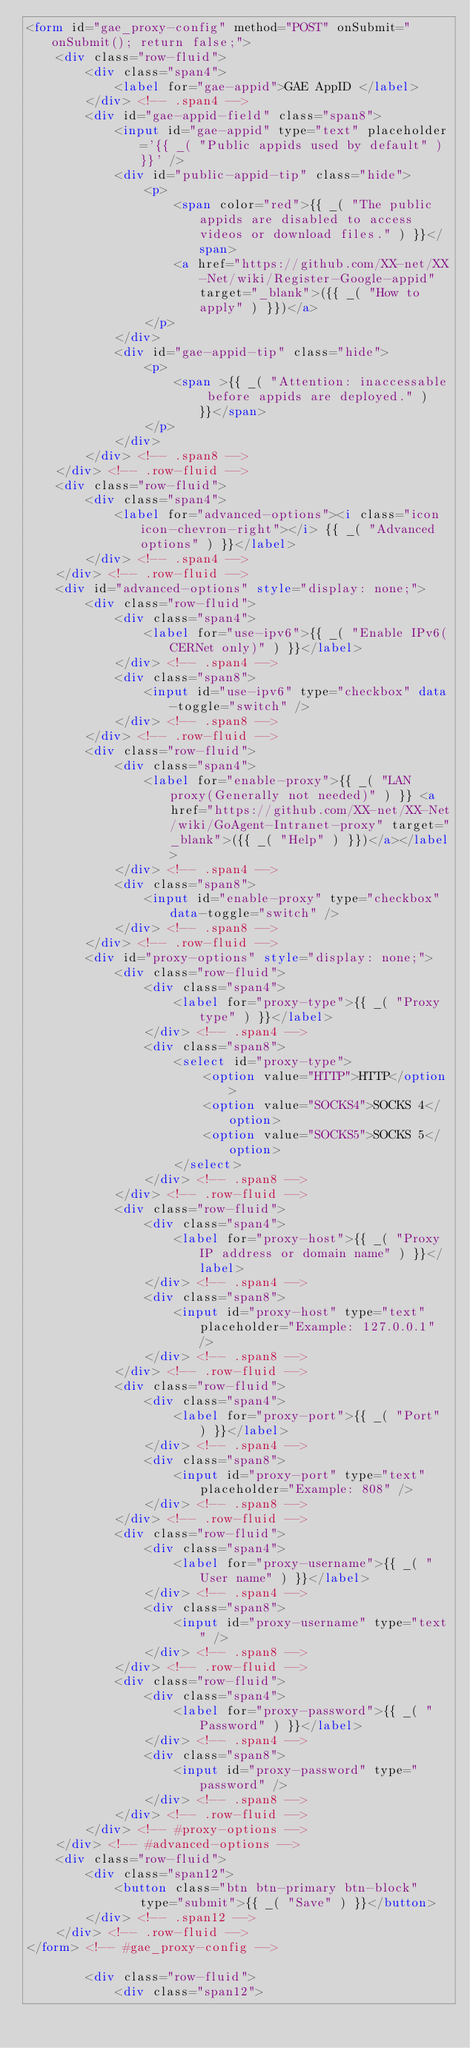Convert code to text. <code><loc_0><loc_0><loc_500><loc_500><_HTML_><form id="gae_proxy-config" method="POST" onSubmit="onSubmit(); return false;">
    <div class="row-fluid">
        <div class="span4">
            <label for="gae-appid">GAE AppID </label>
        </div> <!-- .span4 -->
        <div id="gae-appid-field" class="span8">
            <input id="gae-appid" type="text" placeholder='{{ _( "Public appids used by default" ) }}' />
            <div id="public-appid-tip" class="hide">
                <p>
                    <span color="red">{{ _( "The public appids are disabled to access videos or download files." ) }}</span>
                    <a href="https://github.com/XX-net/XX-Net/wiki/Register-Google-appid" target="_blank">({{ _( "How to apply" ) }})</a>
                </p>
            </div>
            <div id="gae-appid-tip" class="hide">
                <p>
                    <span >{{ _( "Attention: inaccessable before appids are deployed." ) }}</span>
                </p>
            </div>
        </div> <!-- .span8 -->
    </div> <!-- .row-fluid -->
    <div class="row-fluid">
        <div class="span4">
            <label for="advanced-options"><i class="icon icon-chevron-right"></i> {{ _( "Advanced options" ) }}</label>
        </div> <!-- .span4 -->
    </div> <!-- .row-fluid -->
    <div id="advanced-options" style="display: none;">
        <div class="row-fluid">
            <div class="span4">
                <label for="use-ipv6">{{ _( "Enable IPv6(CERNet only)" ) }}</label>
            </div> <!-- .span4 -->
            <div class="span8">
                <input id="use-ipv6" type="checkbox" data-toggle="switch" />
            </div> <!-- .span8 -->
        </div> <!-- .row-fluid -->
        <div class="row-fluid">
            <div class="span4">
                <label for="enable-proxy">{{ _( "LAN proxy(Generally not needed)" ) }} <a href="https://github.com/XX-net/XX-Net/wiki/GoAgent-Intranet-proxy" target="_blank">({{ _( "Help" ) }})</a></label>
            </div> <!-- .span4 -->
            <div class="span8">
                <input id="enable-proxy" type="checkbox" data-toggle="switch" />
            </div> <!-- .span8 -->
        </div> <!-- .row-fluid -->
        <div id="proxy-options" style="display: none;">
            <div class="row-fluid">
                <div class="span4">
                    <label for="proxy-type">{{ _( "Proxy type" ) }}</label>
                </div> <!-- .span4 -->
                <div class="span8">
                    <select id="proxy-type">
                        <option value="HTTP">HTTP</option>
                        <option value="SOCKS4">SOCKS 4</option>
                        <option value="SOCKS5">SOCKS 5</option>
                    </select>
                </div> <!-- .span8 -->
            </div> <!-- .row-fluid -->
            <div class="row-fluid">
                <div class="span4">
                    <label for="proxy-host">{{ _( "Proxy IP address or domain name" ) }}</label>
                </div> <!-- .span4 -->
                <div class="span8">
                    <input id="proxy-host" type="text" placeholder="Example: 127.0.0.1" />
                </div> <!-- .span8 -->
            </div> <!-- .row-fluid -->
            <div class="row-fluid">
                <div class="span4">
                    <label for="proxy-port">{{ _( "Port" ) }}</label>
                </div> <!-- .span4 -->
                <div class="span8">
                    <input id="proxy-port" type="text" placeholder="Example: 808" />
                </div> <!-- .span8 -->
            </div> <!-- .row-fluid -->
            <div class="row-fluid">
                <div class="span4">
                    <label for="proxy-username">{{ _( "User name" ) }}</label>
                </div> <!-- .span4 -->
                <div class="span8">
                    <input id="proxy-username" type="text" />
                </div> <!-- .span8 -->
            </div> <!-- .row-fluid -->
            <div class="row-fluid">
                <div class="span4">
                    <label for="proxy-password">{{ _( "Password" ) }}</label>
                </div> <!-- .span4 -->
                <div class="span8">
                    <input id="proxy-password" type="password" />
                </div> <!-- .span8 -->
            </div> <!-- .row-fluid -->
        </div> <!-- #proxy-options -->
    </div> <!-- #advanced-options -->
    <div class="row-fluid">
        <div class="span12">
            <button class="btn btn-primary btn-block" type="submit">{{ _( "Save" ) }}</button>
        </div> <!-- .span12 -->
    </div> <!-- .row-fluid -->
</form> <!-- #gae_proxy-config -->

        <div class="row-fluid">
            <div class="span12"></code> 